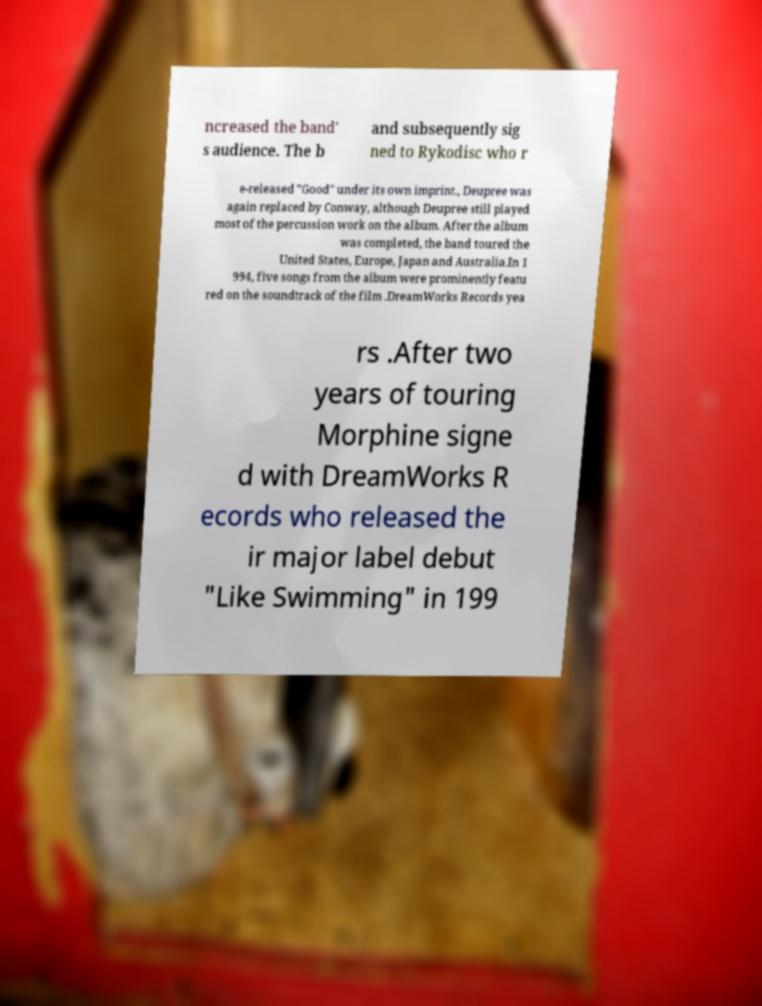I need the written content from this picture converted into text. Can you do that? ncreased the band' s audience. The b and subsequently sig ned to Rykodisc who r e-released "Good" under its own imprint., Deupree was again replaced by Conway, although Deupree still played most of the percussion work on the album. After the album was completed, the band toured the United States, Europe, Japan and Australia.In 1 994, five songs from the album were prominently featu red on the soundtrack of the film .DreamWorks Records yea rs .After two years of touring Morphine signe d with DreamWorks R ecords who released the ir major label debut "Like Swimming" in 199 